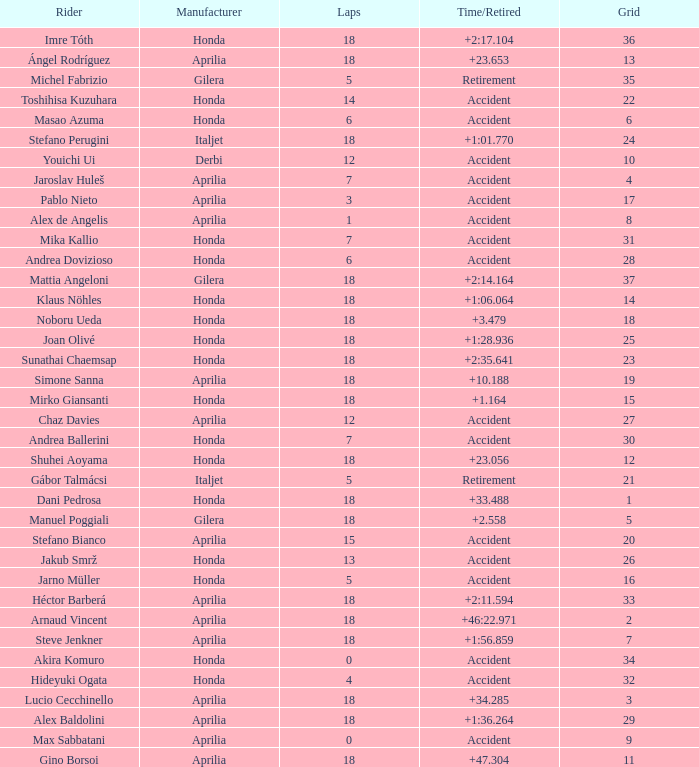Who is the rider with less than 15 laps, more than 32 grids, and an accident time/retired? Akira Komuro. 